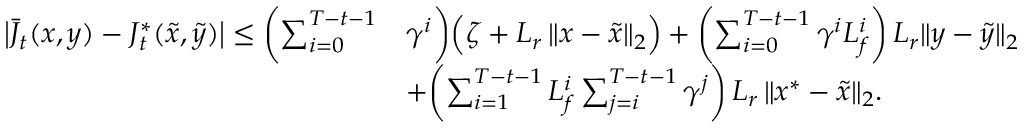Convert formula to latex. <formula><loc_0><loc_0><loc_500><loc_500>\begin{array} { r l } { \left | \bar { J } _ { t } ( x , y ) - J _ { t } ^ { * } ( \tilde { x } , \tilde { y } ) \right | \leq \left ( \sum _ { i = 0 } ^ { T - t - 1 } } & { \gamma ^ { i } \right ) \left ( \zeta + L _ { r } \, \| x - \tilde { x } \| _ { 2 } \right ) + \left ( \sum _ { i = 0 } ^ { T - t - 1 } \gamma ^ { i } L _ { f } ^ { i } \right ) \, L _ { r } \| y - \tilde { y } \| _ { 2 } } \\ & { + \left ( \sum _ { i = 1 } ^ { T - t - 1 } L _ { f } ^ { i } \sum _ { j = i } ^ { T - t - 1 } \gamma ^ { j } \right ) \, L _ { r } \, \| x ^ { * } - \tilde { x } \| _ { 2 } . } \end{array}</formula> 